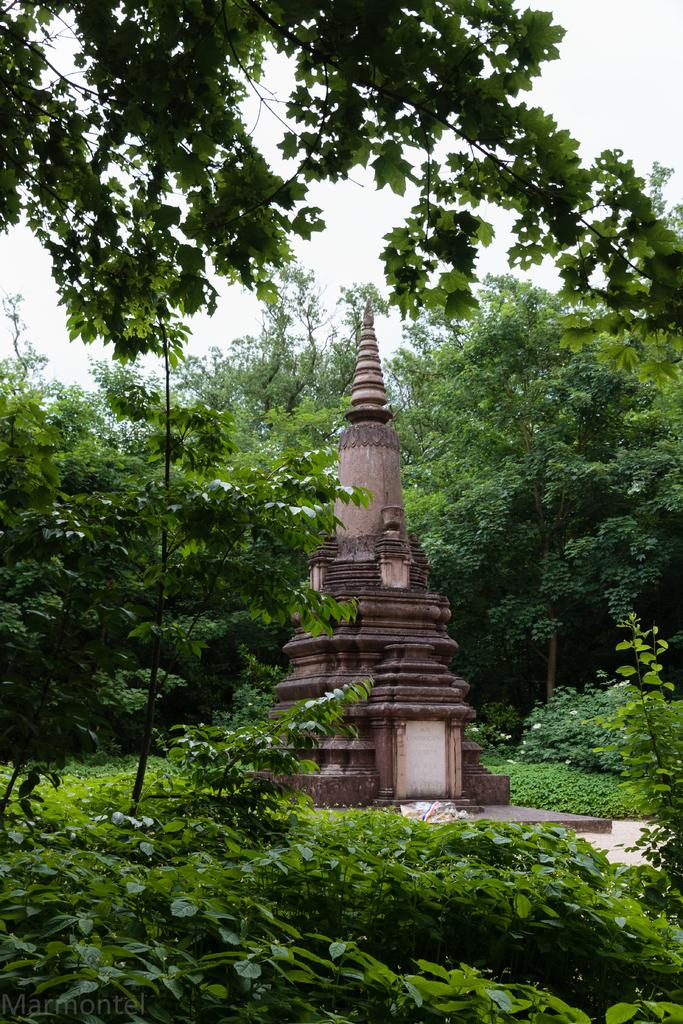What is the main subject of the image? The main subject of the image is a temple construction. What can be seen in the foreground of the image? There are plants in the foreground of the image. What is visible in the background of the image? There are trees in the background of the image. Can you see a playground near the temple construction in the image? There is no playground visible in the image. What type of tail is attached to the minister in the image? There is no minister or any tails present in the image. 